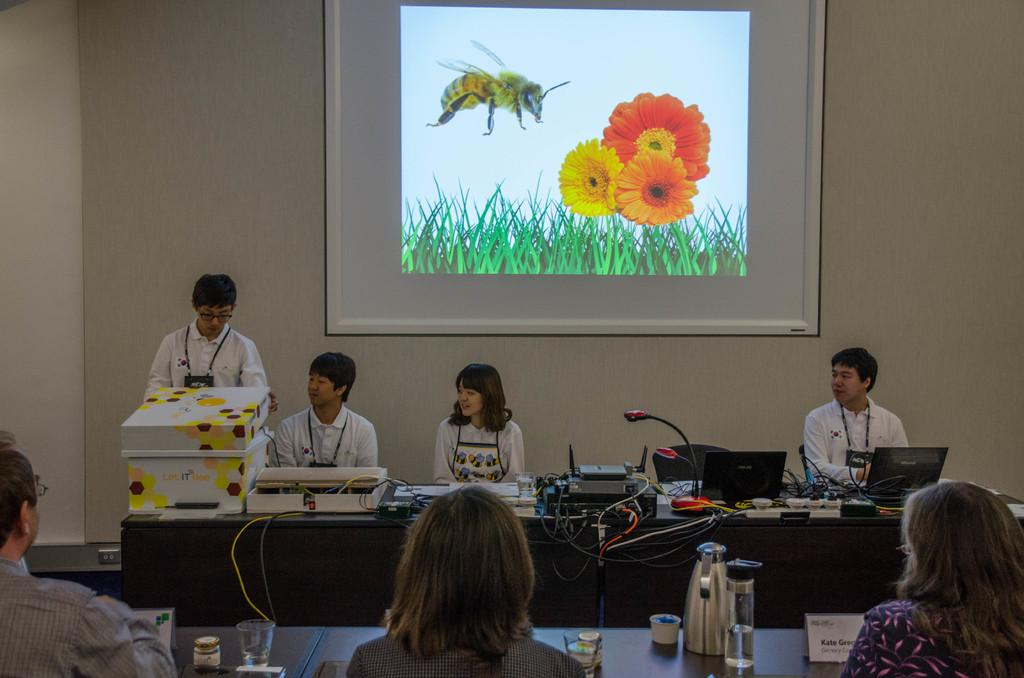How many people are in the image? There is a group of people in the image. What is the boy in the image doing? The boy is giving a presentation. What can be seen behind the boy? There is a screen behind the boy. What type of plastic object is being used to resolve an argument in the image? There is no plastic object being used to resolve an argument in the image, nor is there any indication of an argument taking place. 